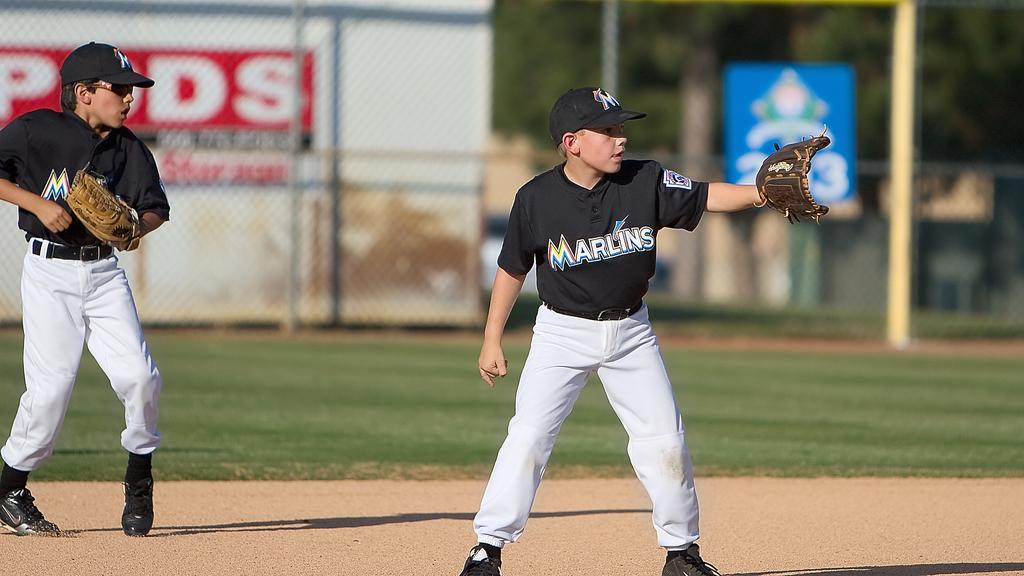<image>
Describe the image concisely. A game of baseball with two of the Marlins team doing the pitching. 